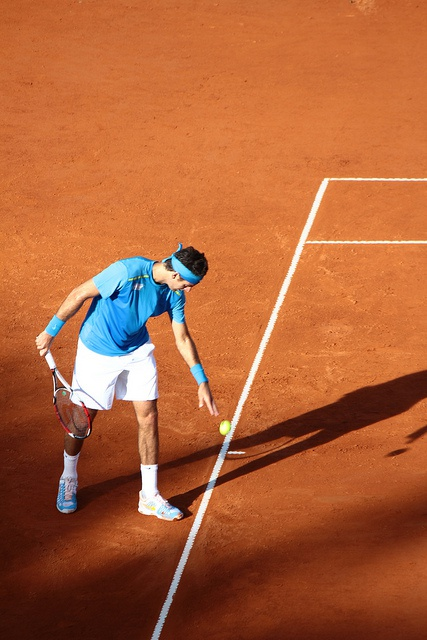Describe the objects in this image and their specific colors. I can see people in red, white, and lightblue tones, tennis racket in red, brown, white, and maroon tones, and sports ball in red, yellow, lightyellow, and khaki tones in this image. 